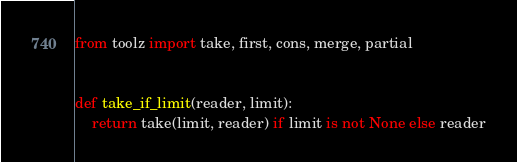<code> <loc_0><loc_0><loc_500><loc_500><_Python_>from toolz import take, first, cons, merge, partial


def take_if_limit(reader, limit):
    return take(limit, reader) if limit is not None else reader
</code> 